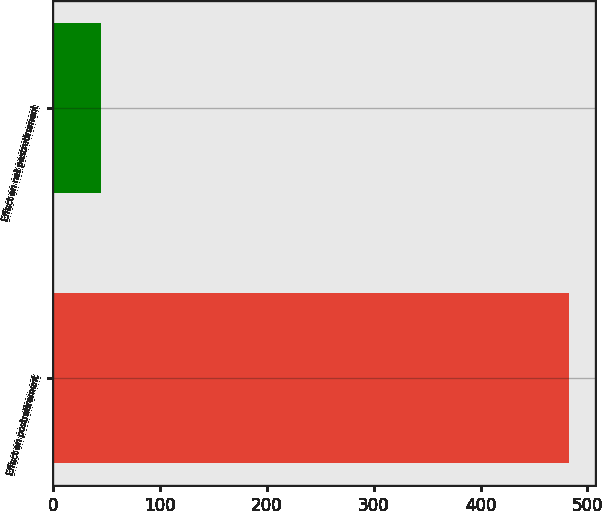Convert chart. <chart><loc_0><loc_0><loc_500><loc_500><bar_chart><fcel>Effect on postretirement<fcel>Effect on net postretirement<nl><fcel>483<fcel>45<nl></chart> 